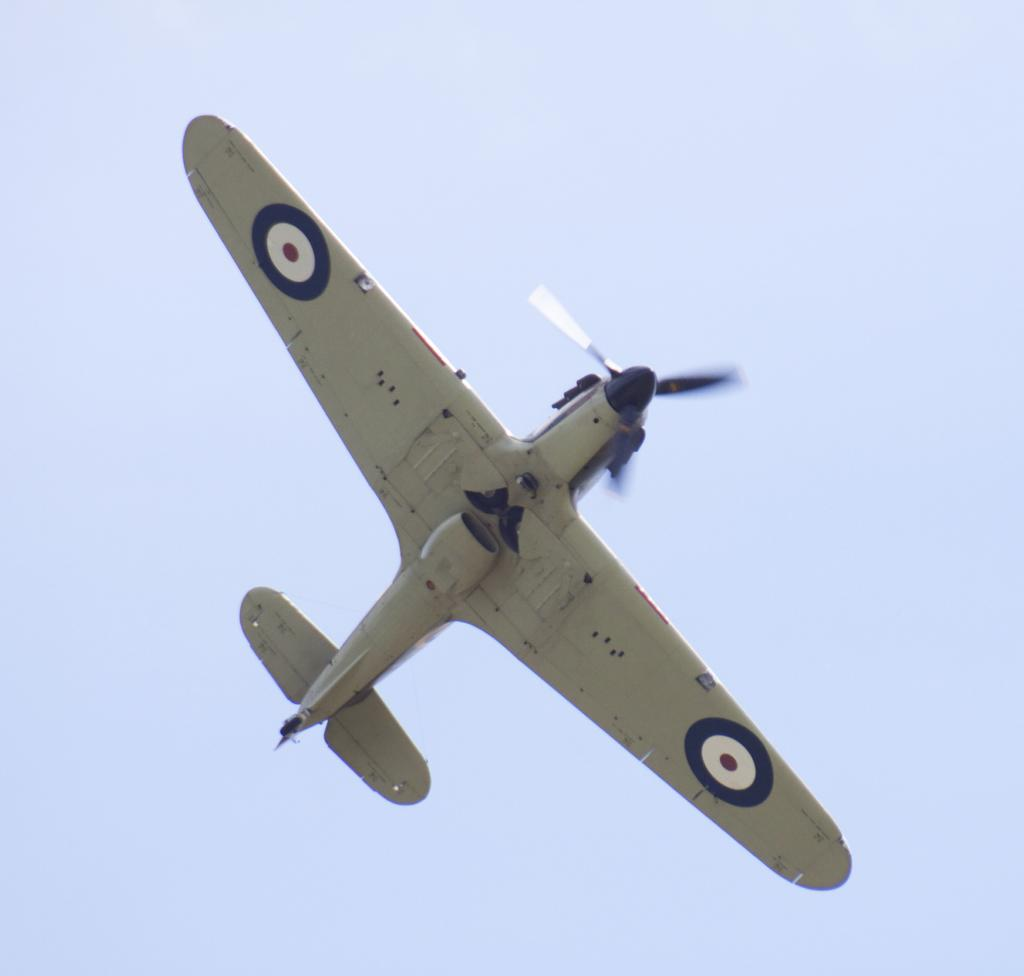What is the main subject of the image? The main subject of the image is an airplane. Where is the airplane located in the image? The airplane is in the sky. Reasoning: Let' Let's think step by step in order to produce the conversation. We start by identifying the main subject of the image, which is the airplane. Then, we describe the location of the airplane, which is in the sky. We avoid yes/no questions and ensure that the language is simple and clear. Absurd Question/Answer: How many cobwebs can be seen on the airplane in the image? There are no cobwebs visible on the airplane in the image. What level of experience does the pilot have in the image? The level of experience of the pilot is not mentioned or visible in the image. 